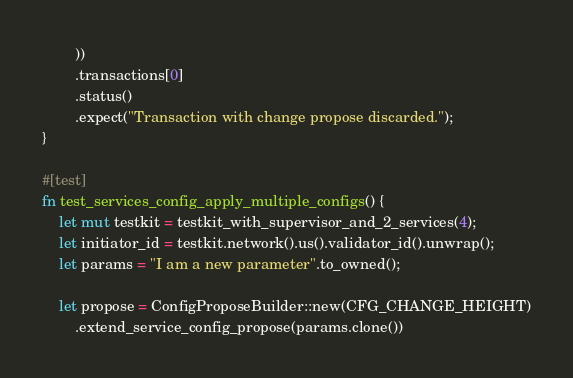Convert code to text. <code><loc_0><loc_0><loc_500><loc_500><_Rust_>        ))
        .transactions[0]
        .status()
        .expect("Transaction with change propose discarded.");
}

#[test]
fn test_services_config_apply_multiple_configs() {
    let mut testkit = testkit_with_supervisor_and_2_services(4);
    let initiator_id = testkit.network().us().validator_id().unwrap();
    let params = "I am a new parameter".to_owned();

    let propose = ConfigProposeBuilder::new(CFG_CHANGE_HEIGHT)
        .extend_service_config_propose(params.clone())</code> 